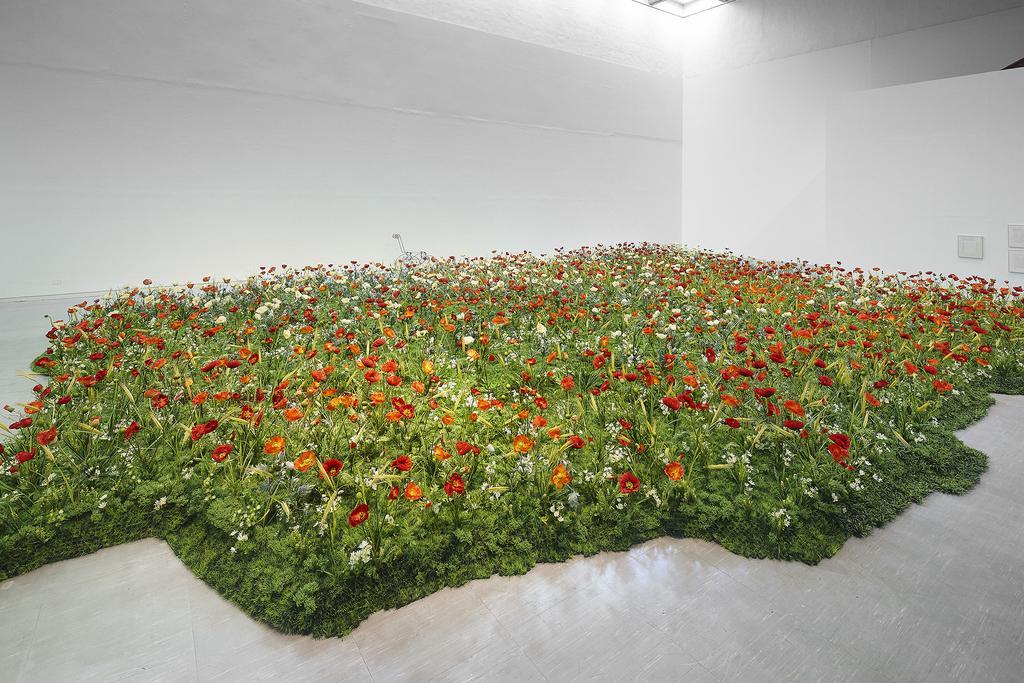How would you summarize this image in a sentence or two? In this picture I can see many flowers on the plants. At the top I can see the light beam on the roof. On the right I can see the frame which are placed on the wall. 